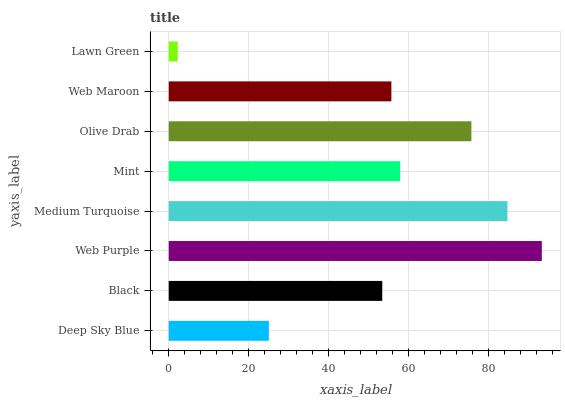Is Lawn Green the minimum?
Answer yes or no. Yes. Is Web Purple the maximum?
Answer yes or no. Yes. Is Black the minimum?
Answer yes or no. No. Is Black the maximum?
Answer yes or no. No. Is Black greater than Deep Sky Blue?
Answer yes or no. Yes. Is Deep Sky Blue less than Black?
Answer yes or no. Yes. Is Deep Sky Blue greater than Black?
Answer yes or no. No. Is Black less than Deep Sky Blue?
Answer yes or no. No. Is Mint the high median?
Answer yes or no. Yes. Is Web Maroon the low median?
Answer yes or no. Yes. Is Web Purple the high median?
Answer yes or no. No. Is Deep Sky Blue the low median?
Answer yes or no. No. 